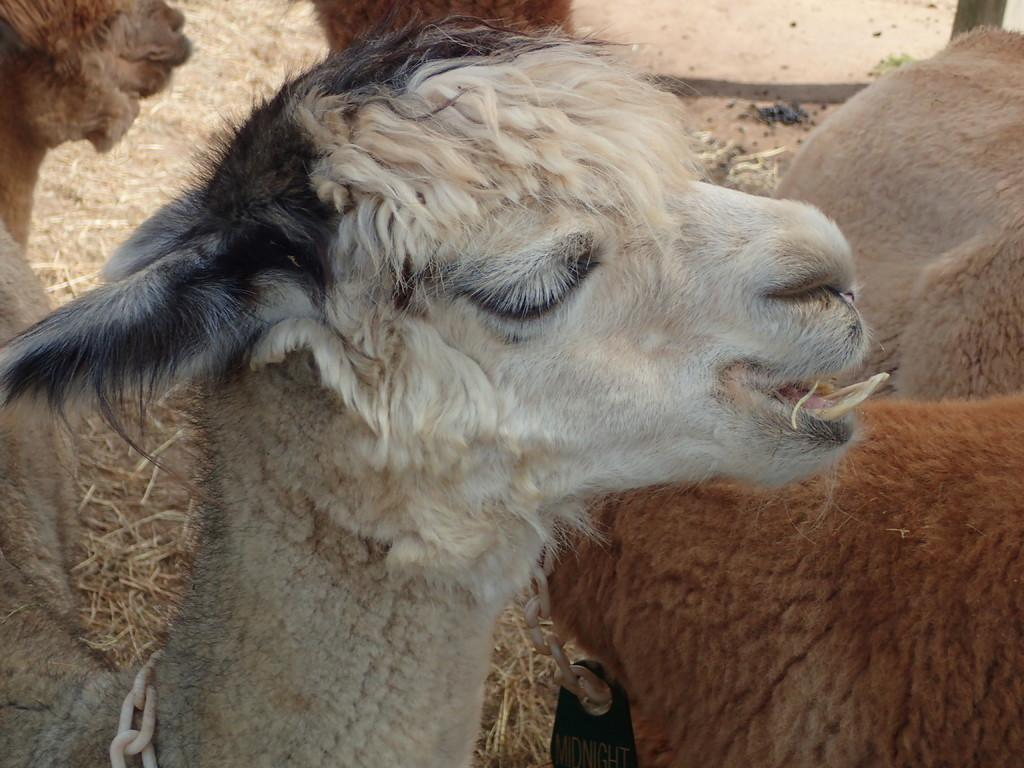What type of animal is present in the image? There is a sheep in the image. What is the color of the first sheep? The first sheep is white in color. Are there any distinguishing features on the first sheep? Yes, the first sheep has some black on its head. How many sheep are in the image? There are two sheep in the image. What is the color of the second sheep? The second sheep is brown in color. What type of zipper can be seen on the sheep in the image? There is no zipper present on the sheep in the image; it is a living animal. 